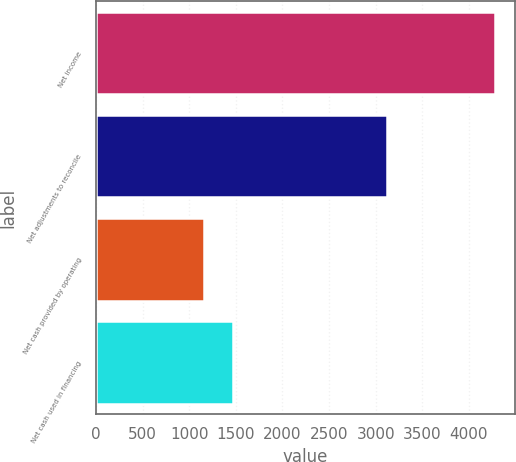<chart> <loc_0><loc_0><loc_500><loc_500><bar_chart><fcel>Net income<fcel>Net adjustments to reconcile<fcel>Net cash provided by operating<fcel>Net cash used in financing<nl><fcel>4279<fcel>3124<fcel>1155<fcel>1467.4<nl></chart> 